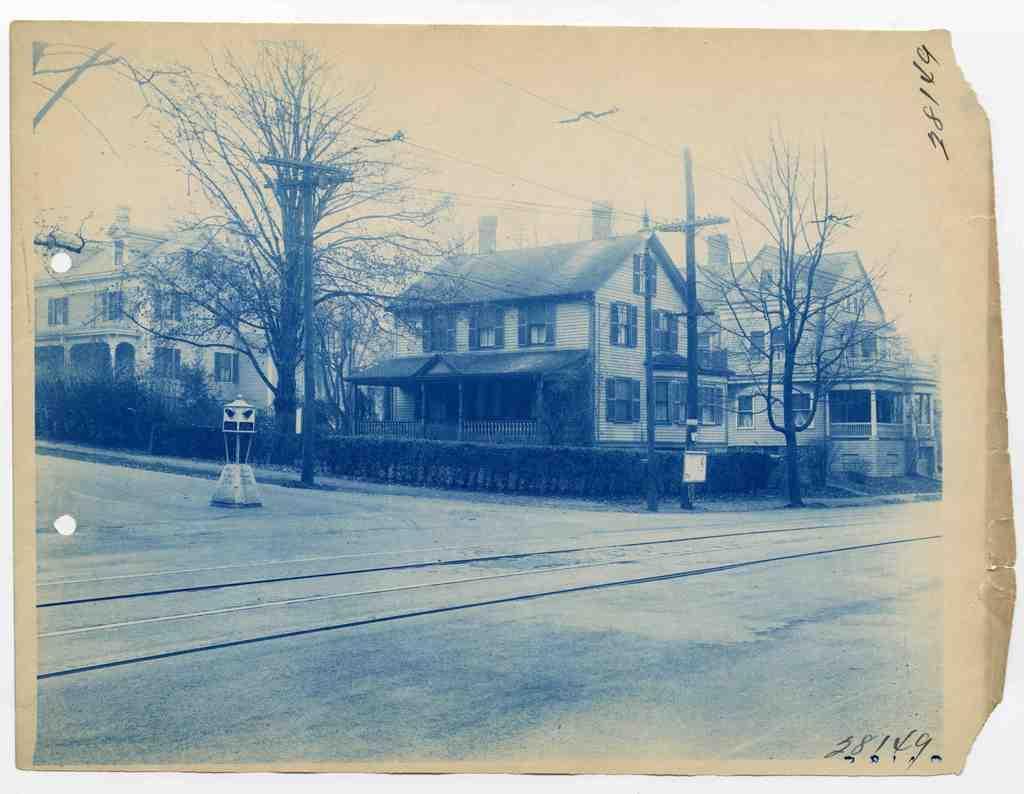Could you give a brief overview of what you see in this image? In this picture there is a photo which is kept on the table. In the center of the photo I can see many buildings, trees and plants. Beside the road I can see the electric poles and wires are connected to it. On the left there are street lights. At the top there is a sky. 